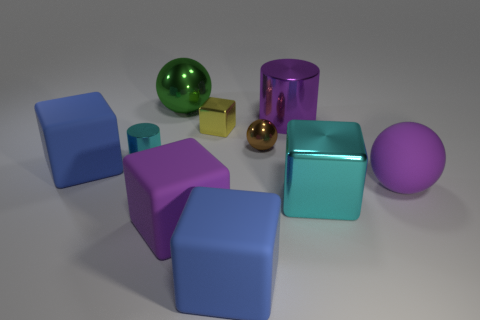There is a large rubber object that is the same color as the rubber ball; what shape is it?
Provide a succinct answer. Cube. There is a large blue object that is on the right side of the big green metal object; what number of cyan metal blocks are to the right of it?
Your answer should be very brief. 1. How many big purple cylinders have the same material as the brown ball?
Your answer should be very brief. 1. Are there any green shiny things behind the large green metal object?
Your answer should be compact. No. What color is the other ball that is the same size as the green metal ball?
Offer a very short reply. Purple. What number of objects are rubber objects on the right side of the cyan shiny cylinder or cubes?
Ensure brevity in your answer.  6. There is a metallic thing that is left of the yellow shiny object and in front of the big purple metal object; what is its size?
Offer a very short reply. Small. There is a object that is the same color as the big metallic cube; what size is it?
Offer a very short reply. Small. How many other things are there of the same size as the purple metallic object?
Provide a short and direct response. 6. What is the color of the metal cylinder to the right of the blue matte cube in front of the large block left of the large green thing?
Your response must be concise. Purple. 